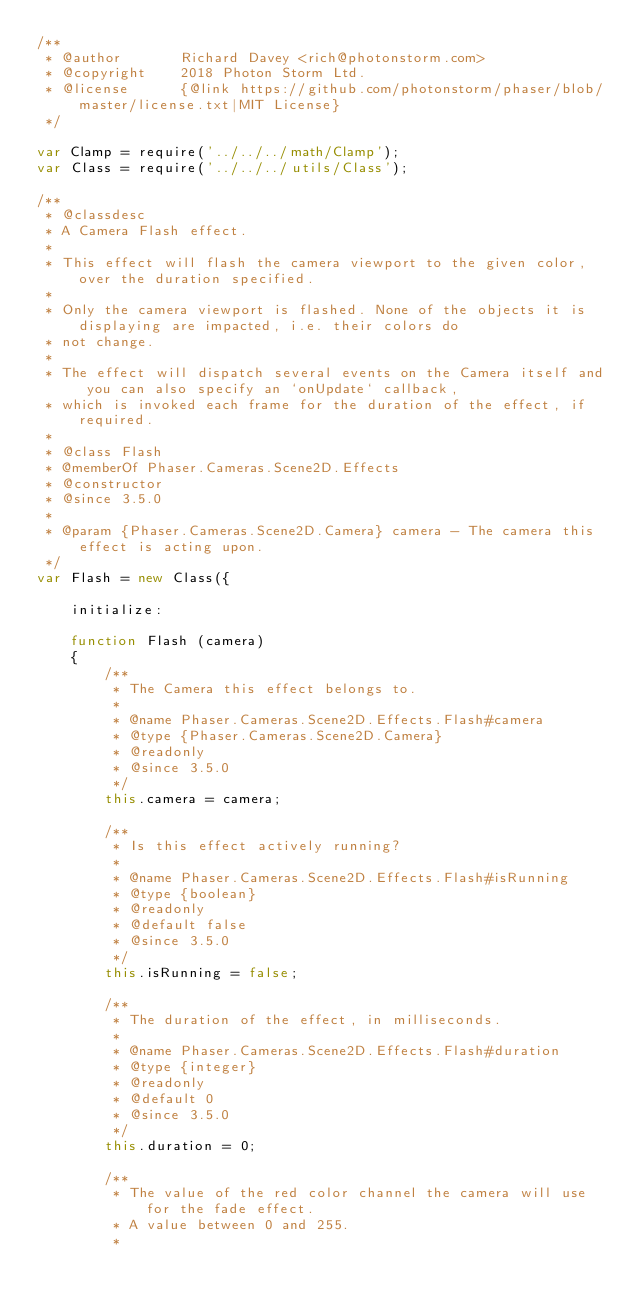Convert code to text. <code><loc_0><loc_0><loc_500><loc_500><_JavaScript_>/**
 * @author       Richard Davey <rich@photonstorm.com>
 * @copyright    2018 Photon Storm Ltd.
 * @license      {@link https://github.com/photonstorm/phaser/blob/master/license.txt|MIT License}
 */

var Clamp = require('../../../math/Clamp');
var Class = require('../../../utils/Class');

/**
 * @classdesc
 * A Camera Flash effect.
 *
 * This effect will flash the camera viewport to the given color, over the duration specified.
 *
 * Only the camera viewport is flashed. None of the objects it is displaying are impacted, i.e. their colors do
 * not change.
 *
 * The effect will dispatch several events on the Camera itself and you can also specify an `onUpdate` callback,
 * which is invoked each frame for the duration of the effect, if required.
 *
 * @class Flash
 * @memberOf Phaser.Cameras.Scene2D.Effects
 * @constructor
 * @since 3.5.0
 *
 * @param {Phaser.Cameras.Scene2D.Camera} camera - The camera this effect is acting upon.
 */
var Flash = new Class({

    initialize:

    function Flash (camera)
    {
        /**
         * The Camera this effect belongs to.
         *
         * @name Phaser.Cameras.Scene2D.Effects.Flash#camera
         * @type {Phaser.Cameras.Scene2D.Camera}
         * @readonly
         * @since 3.5.0
         */
        this.camera = camera;

        /**
         * Is this effect actively running?
         *
         * @name Phaser.Cameras.Scene2D.Effects.Flash#isRunning
         * @type {boolean}
         * @readonly
         * @default false
         * @since 3.5.0
         */
        this.isRunning = false;

        /**
         * The duration of the effect, in milliseconds.
         *
         * @name Phaser.Cameras.Scene2D.Effects.Flash#duration
         * @type {integer}
         * @readonly
         * @default 0
         * @since 3.5.0
         */
        this.duration = 0;

        /**
         * The value of the red color channel the camera will use for the fade effect.
         * A value between 0 and 255.
         *</code> 